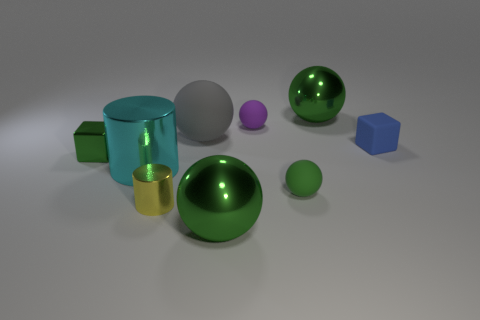Is the number of small purple matte objects to the left of the yellow cylinder greater than the number of green balls that are left of the gray ball?
Your response must be concise. No. There is another big shiny thing that is the same shape as the yellow metallic object; what color is it?
Ensure brevity in your answer.  Cyan. Is there anything else that has the same shape as the tiny purple thing?
Your answer should be compact. Yes. There is a big matte object; is it the same shape as the large green object that is behind the tiny shiny cylinder?
Provide a short and direct response. Yes. How many other things are there of the same material as the small cylinder?
Your answer should be compact. 4. There is a metal block; is it the same color as the small matte sphere in front of the green cube?
Ensure brevity in your answer.  Yes. There is a big green sphere behind the small blue matte cube; what material is it?
Offer a terse response. Metal. Are there any large metal things that have the same color as the tiny shiny block?
Your answer should be compact. Yes. There is a rubber sphere that is the same size as the cyan metal object; what is its color?
Offer a terse response. Gray. How many large objects are purple metal cubes or blue matte blocks?
Provide a short and direct response. 0. 